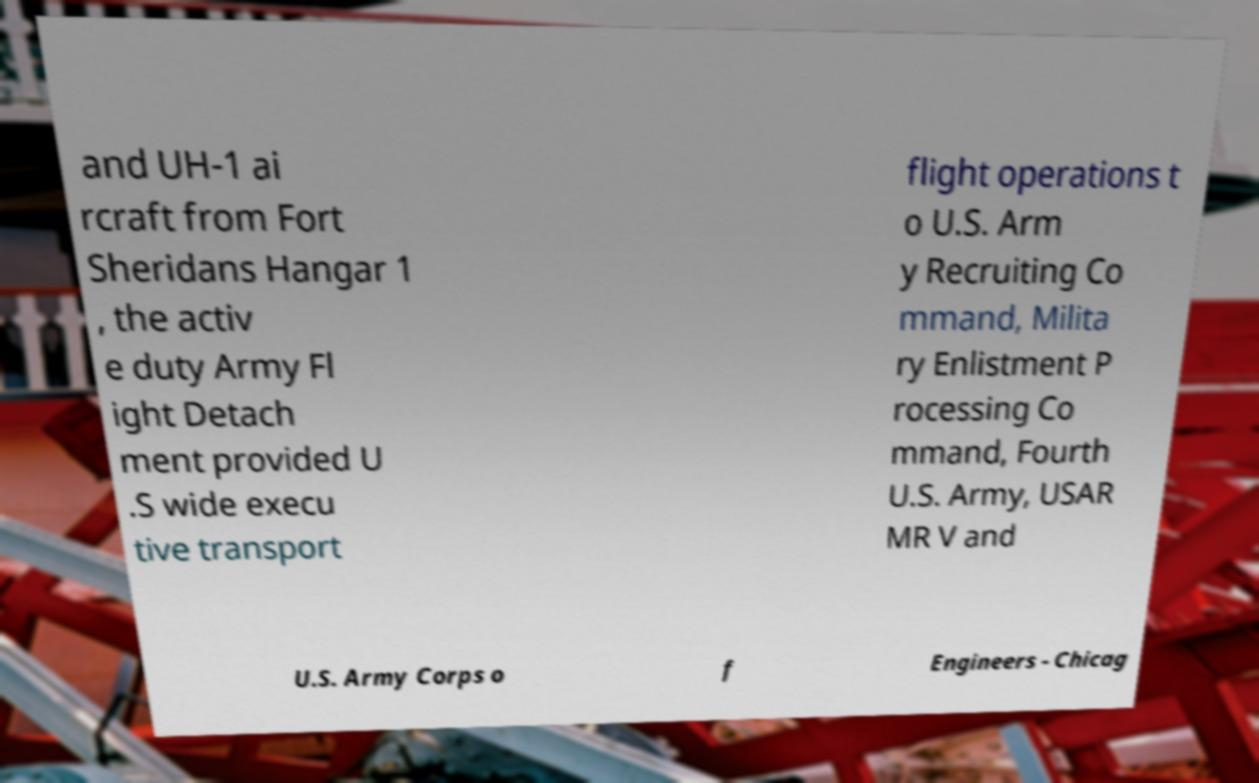Could you extract and type out the text from this image? and UH-1 ai rcraft from Fort Sheridans Hangar 1 , the activ e duty Army Fl ight Detach ment provided U .S wide execu tive transport flight operations t o U.S. Arm y Recruiting Co mmand, Milita ry Enlistment P rocessing Co mmand, Fourth U.S. Army, USAR MR V and U.S. Army Corps o f Engineers - Chicag 